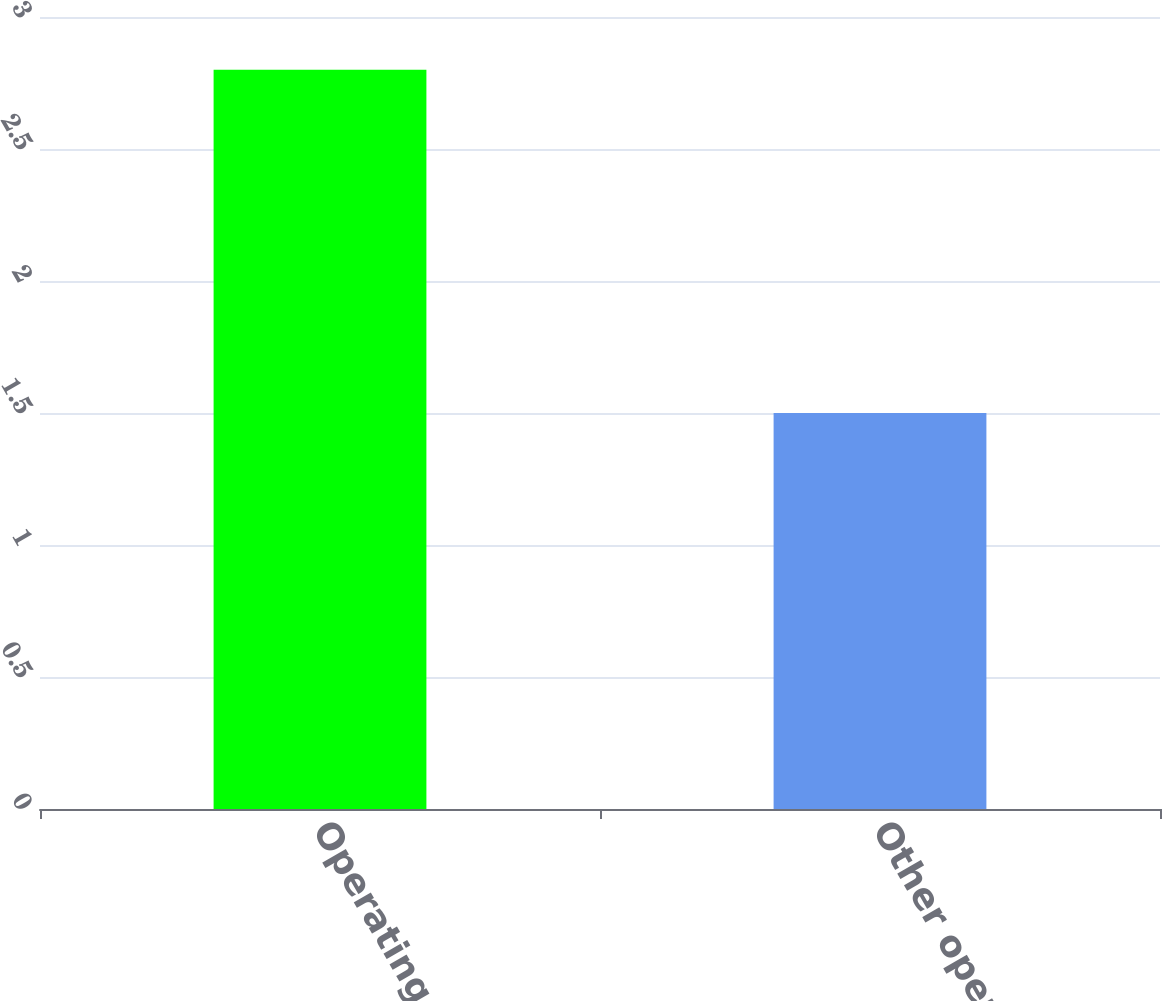Convert chart to OTSL. <chart><loc_0><loc_0><loc_500><loc_500><bar_chart><fcel>Operating revenues<fcel>Other operations and<nl><fcel>2.8<fcel>1.5<nl></chart> 